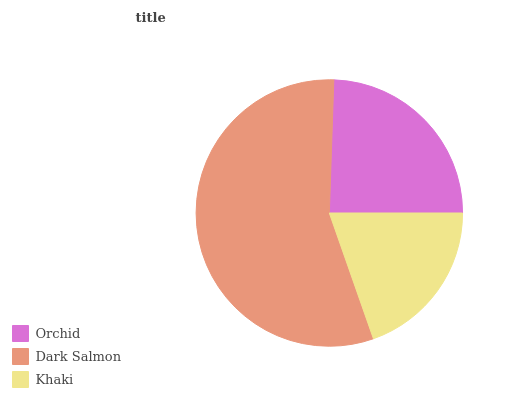Is Khaki the minimum?
Answer yes or no. Yes. Is Dark Salmon the maximum?
Answer yes or no. Yes. Is Dark Salmon the minimum?
Answer yes or no. No. Is Khaki the maximum?
Answer yes or no. No. Is Dark Salmon greater than Khaki?
Answer yes or no. Yes. Is Khaki less than Dark Salmon?
Answer yes or no. Yes. Is Khaki greater than Dark Salmon?
Answer yes or no. No. Is Dark Salmon less than Khaki?
Answer yes or no. No. Is Orchid the high median?
Answer yes or no. Yes. Is Orchid the low median?
Answer yes or no. Yes. Is Khaki the high median?
Answer yes or no. No. Is Dark Salmon the low median?
Answer yes or no. No. 